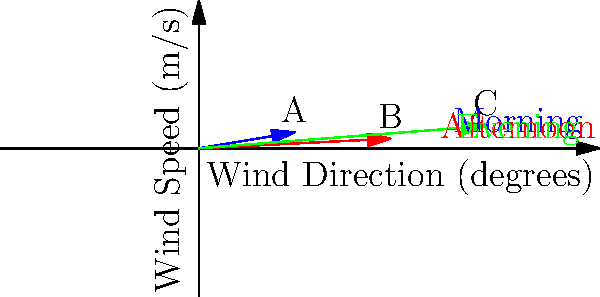As an avid rock climber in California, you're planning a climb at Joshua Tree National Park. The vector diagram shows wind patterns throughout the day. Vector A (blue) represents morning winds, B (red) afternoon winds, and C (green) evening winds. Which time of day would likely present the most challenging climbing conditions, and what is the magnitude of the wind vector for that time period? To determine the most challenging climbing conditions and the magnitude of the corresponding wind vector, we need to analyze each vector:

1. Calculate the magnitude of each vector using the Pythagorean theorem: $\sqrt{x^2 + y^2}$

   Vector A (morning): $\sqrt{30^2 + 5^2} \approx 30.41$ m/s
   Vector B (afternoon): $\sqrt{60^2 + 3^2} \approx 60.15$ m/s
   Vector C (evening): $\sqrt{90^2 + 7^2} \approx 90.27$ m/s

2. Compare the magnitudes:
   Vector C has the largest magnitude, followed by B, then A.

3. Consider the impact on climbing:
   Stronger winds generally make climbing more challenging due to increased risk of losing balance, difficulty in rope management, and potential for loose debris.

4. Evaluate the wind directions:
   Vector C is also more perpendicular to the typical climbing surface (assuming vertical or near-vertical faces), which could create more lateral force on the climber.

5. Conclusion:
   The evening winds (Vector C) would likely present the most challenging climbing conditions due to their higher magnitude and more perpendicular direction relative to typical climbing surfaces.

The magnitude of Vector C is approximately 90.27 m/s.
Answer: Evening; 90.27 m/s 